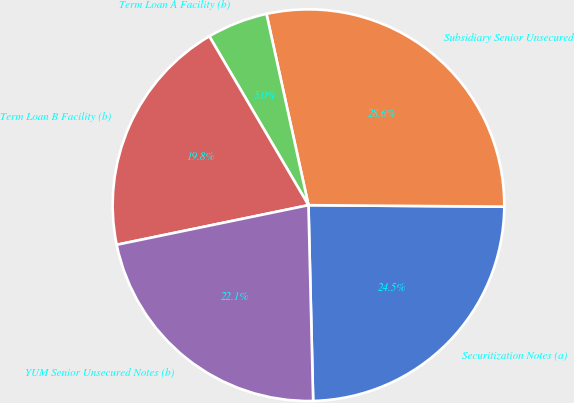<chart> <loc_0><loc_0><loc_500><loc_500><pie_chart><fcel>Securitization Notes (a)<fcel>Subsidiary Senior Unsecured<fcel>Term Loan A Facility (b)<fcel>Term Loan B Facility (b)<fcel>YUM Senior Unsecured Notes (b)<nl><fcel>24.5%<fcel>28.56%<fcel>5.01%<fcel>19.79%<fcel>22.14%<nl></chart> 